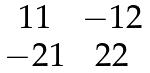<formula> <loc_0><loc_0><loc_500><loc_500>\begin{matrix} 1 1 & - 1 2 \\ - 2 1 & 2 2 \end{matrix}</formula> 